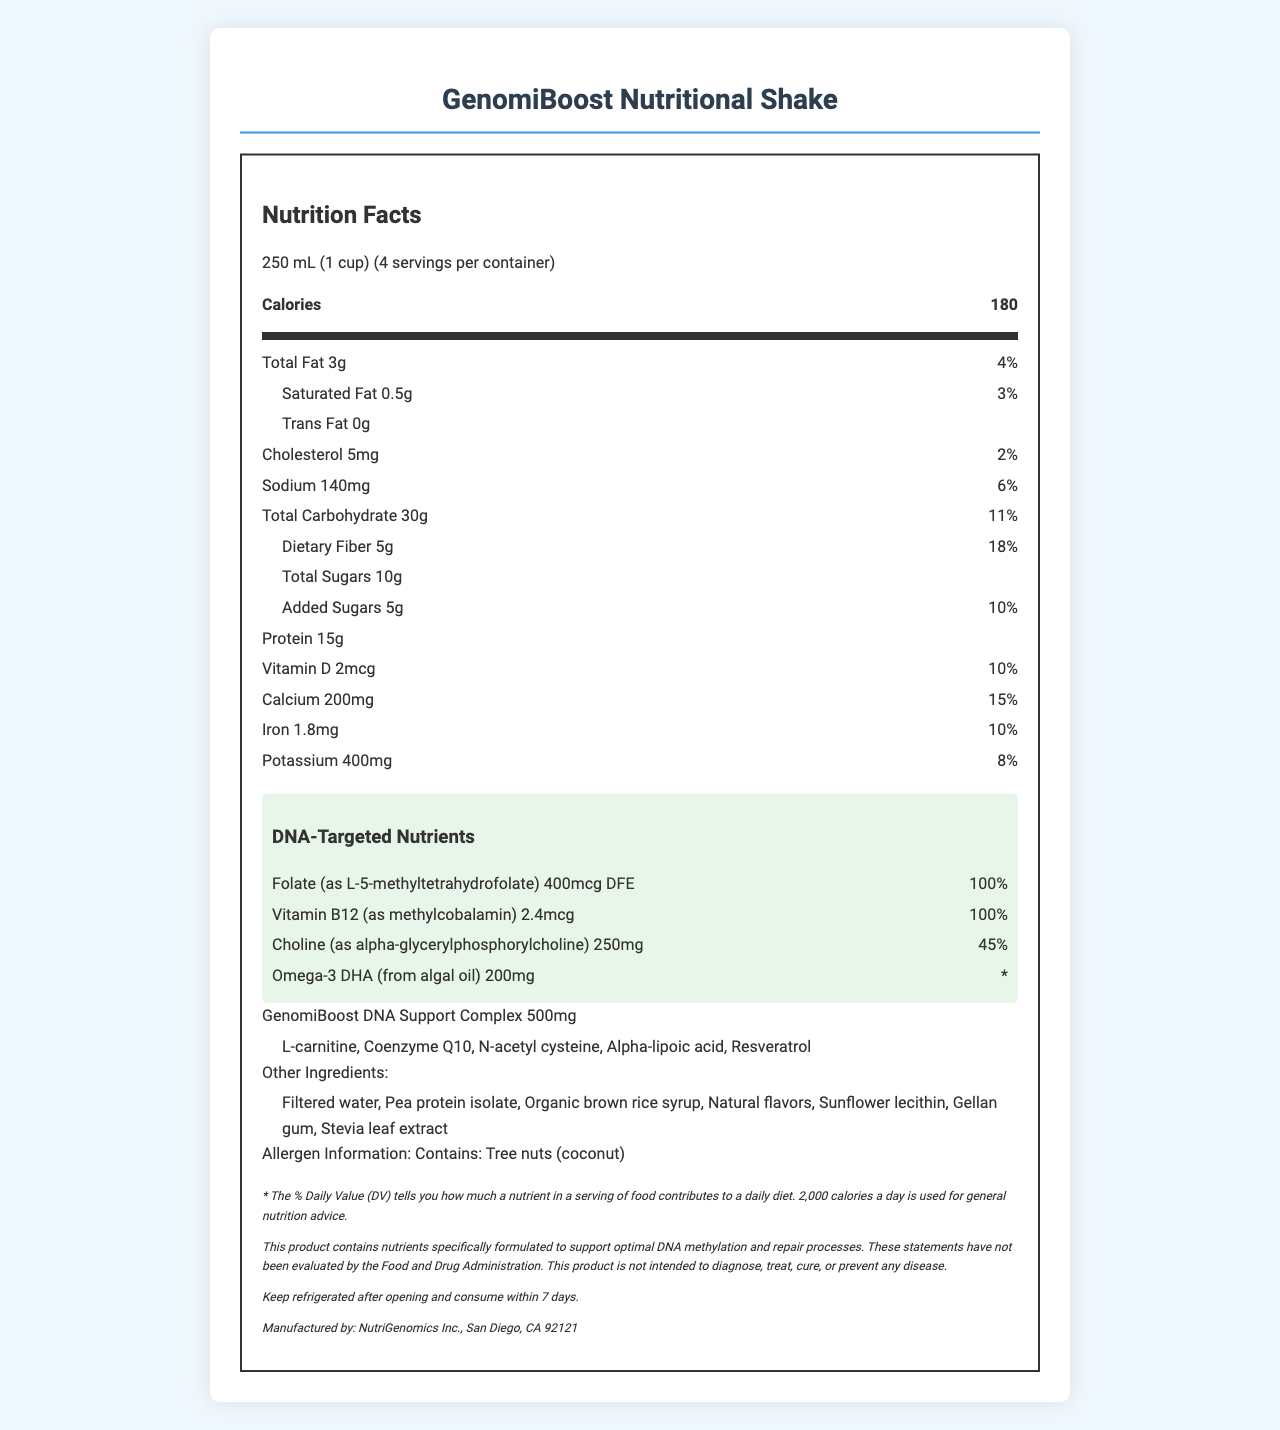what is the serving size? The document states the serving size as 250 mL (1 cup).
Answer: 250 mL (1 cup) how many servings are there per container? The document mentions that there are 4 servings per container.
Answer: 4 how many calories are there per serving? The document lists 180 calories per serving.
Answer: 180 what is the total amount of fat in one serving? The label indicates the total fat content as 3g per serving.
Answer: 3g what are the included allergens in this product? The allergen information specifies that the product contains tree nuts (coconut).
Answer: Tree nuts (coconut) which of the following nutrients is present in the highest amount relative to its daily value? A. Vitamin D B. Calcium C. Folate D. Iron Folate has a daily value of 100%, which is the highest among the listed nutrients.
Answer: C how much Omega-3 DHA is in one serving? A. 200mcg B. 200mg C. 250mg D. 2.4mcg The document indicates that the Omega-3 DHA content is 200mg.
Answer: B does this product contain any trans fat? The document lists 0g of trans fat.
Answer: No what is the main purpose of the DNA-targeted nutrients mentioned in the document? The document states that the DNA-targeted nutrients are formulated to support DNA methylation and repair processes.
Answer: To support optimal DNA methylation and repair processes how many ingredients are in the proprietary blend mentioned? The proprietary blend includes L-carnitine, Coenzyme Q10, N-acetyl cysteine, Alpha-lipoic acid, and Resveratrol, totaling 5 ingredients.
Answer: 5 what is the protein content per serving? The label indicates that each serving contains 15g of protein.
Answer: 15g how much choline is present in one serving, and what is its daily value percentage? The document shows that there is 250mg of choline per serving, which is 45% of the daily value.
Answer: 250mg, 45% how should the product be stored after opening? The storage instructions specify to keep the product refrigerated and consume it within 7 days after opening.
Answer: Keep refrigerated and consume within 7 days which of the ingredients listed is not part of the proprietary blend? A. Coenzyme Q10 B. L-carnitine C. Stevia leaf extract D. N-acetyl cysteine Stevia leaf extract is listed under "Other Ingredients," not the proprietary blend.
Answer: C is the daily value percentage of dietary fiber above 15%? The daily value percentage for dietary fiber is 18%, which is above 15%.
Answer: Yes summarize the main content of the document. This summary captures the key elements provided in the Nutrition Facts Label, detailing the contents and purpose of the product as well as important consumer information.
Answer: The document provides the nutrition facts for "GenomiBoost Nutritional Shake," detailing the serving size, servings per container, calories, macronutrients, vitamins, and minerals present in each serving. It highlights the inclusion of DNA-targeted nutrients such as Folate, Vitamin B12, Choline, and Omega-3 DHA, along with a proprietary blend of several ingredients. Allergen information and storage instructions are also given, along with a disclaimer concerning the product's intended use and evaluation by the FDA. what is the exact amount of each type of protein in the shake? The document only provides the total protein content per serving (15g) but does not specify the types or amounts of each specific protein.
Answer: Cannot be determined 